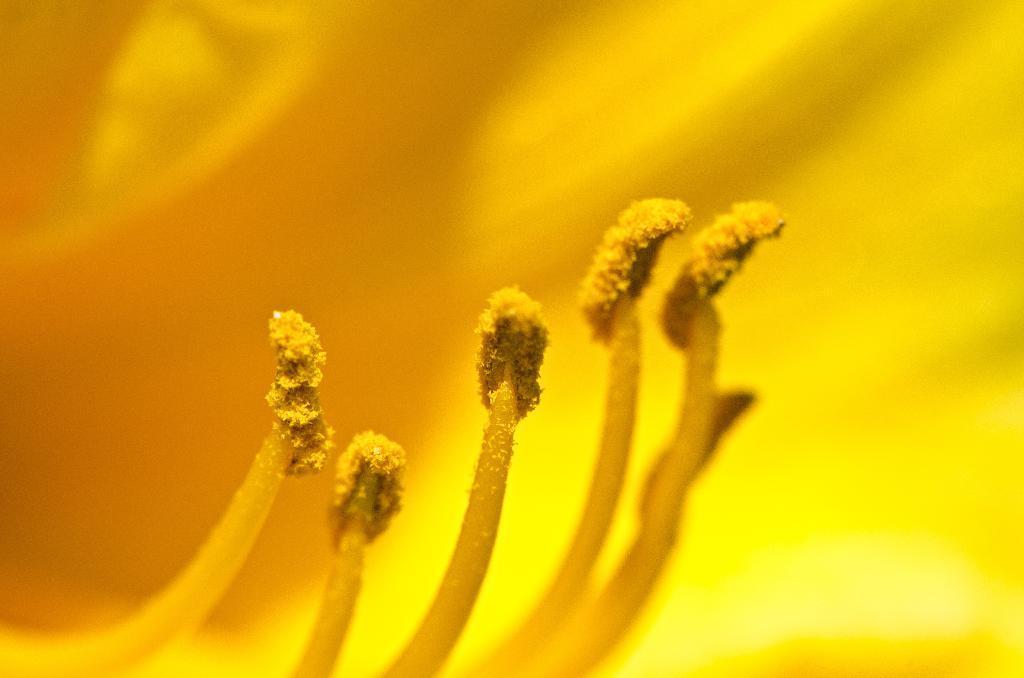Can you describe this image briefly? In this image I can see the flower in yellow color. 